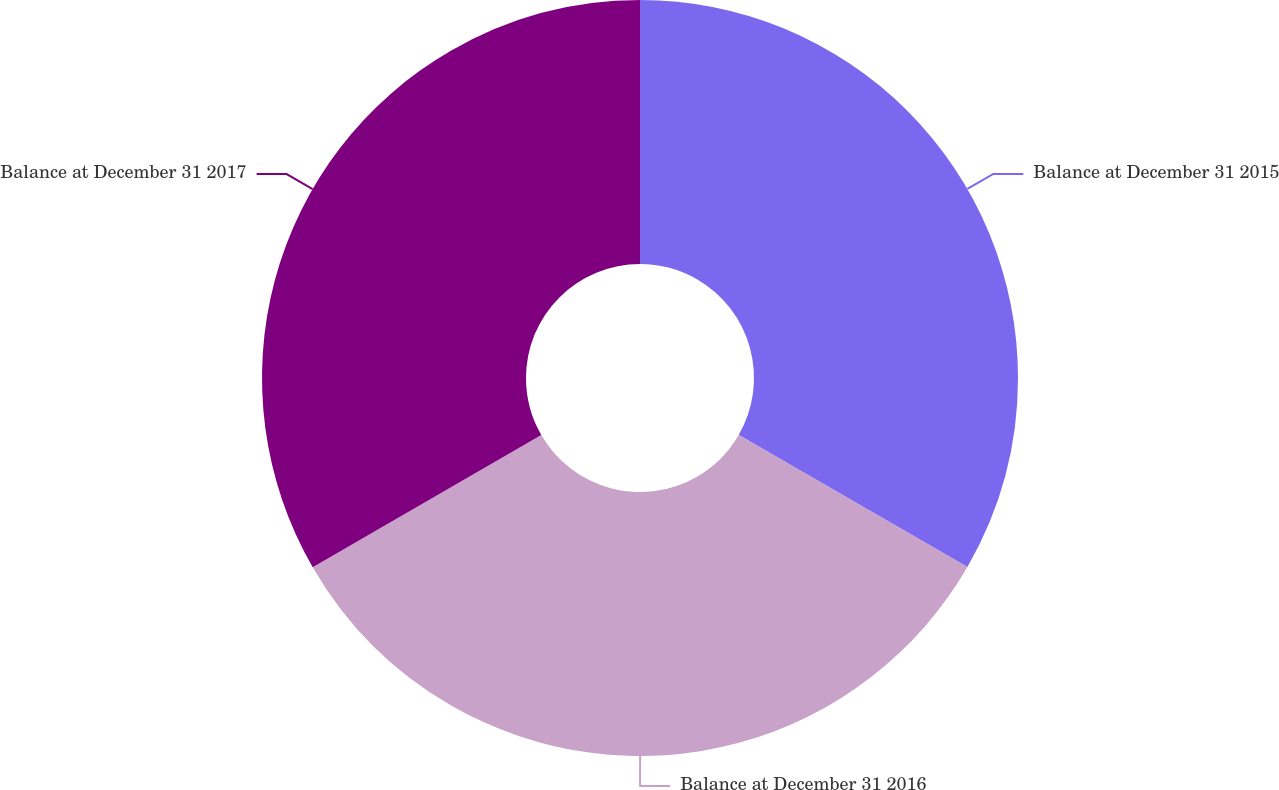<chart> <loc_0><loc_0><loc_500><loc_500><pie_chart><fcel>Balance at December 31 2015<fcel>Balance at December 31 2016<fcel>Balance at December 31 2017<nl><fcel>33.33%<fcel>33.33%<fcel>33.34%<nl></chart> 